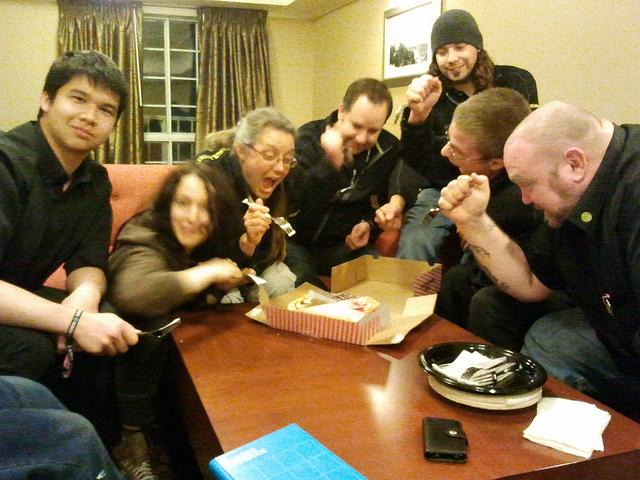What is on the man on the right's forearm?
Write a very short answer. Tattoo. How many people are wearing glasses?
Write a very short answer. 2. Are these people all eating out of same box?
Quick response, please. Yes. 